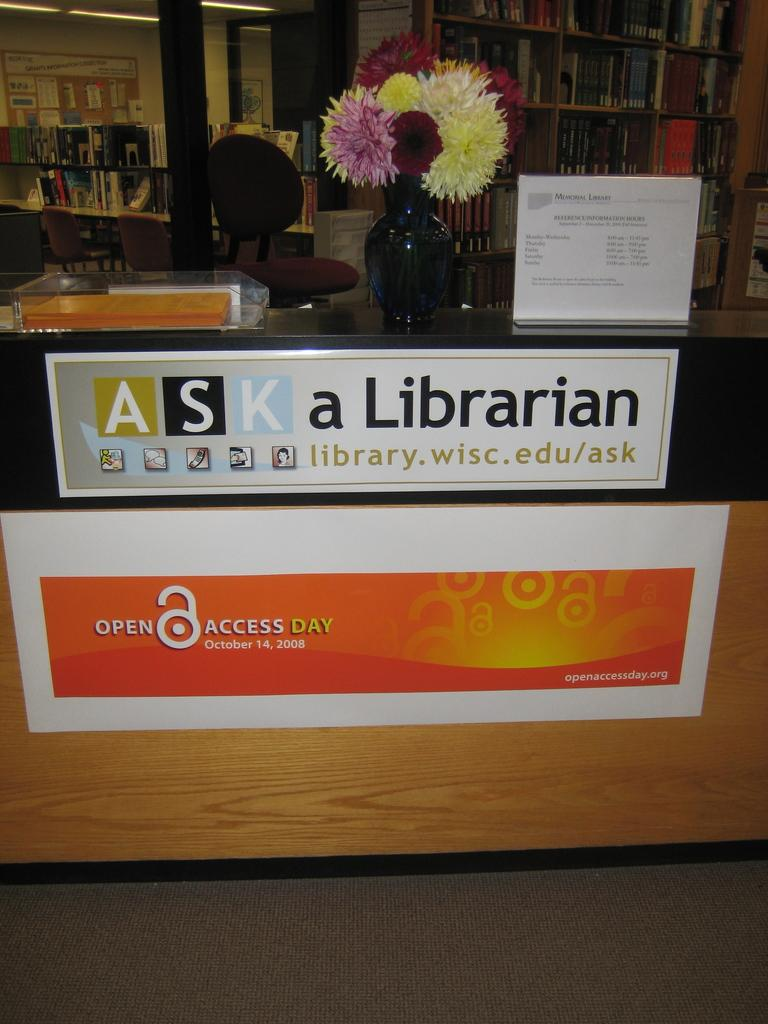Provide a one-sentence caption for the provided image. Front desk with a vase of flowers and a sign that says Ask a Librarian. 